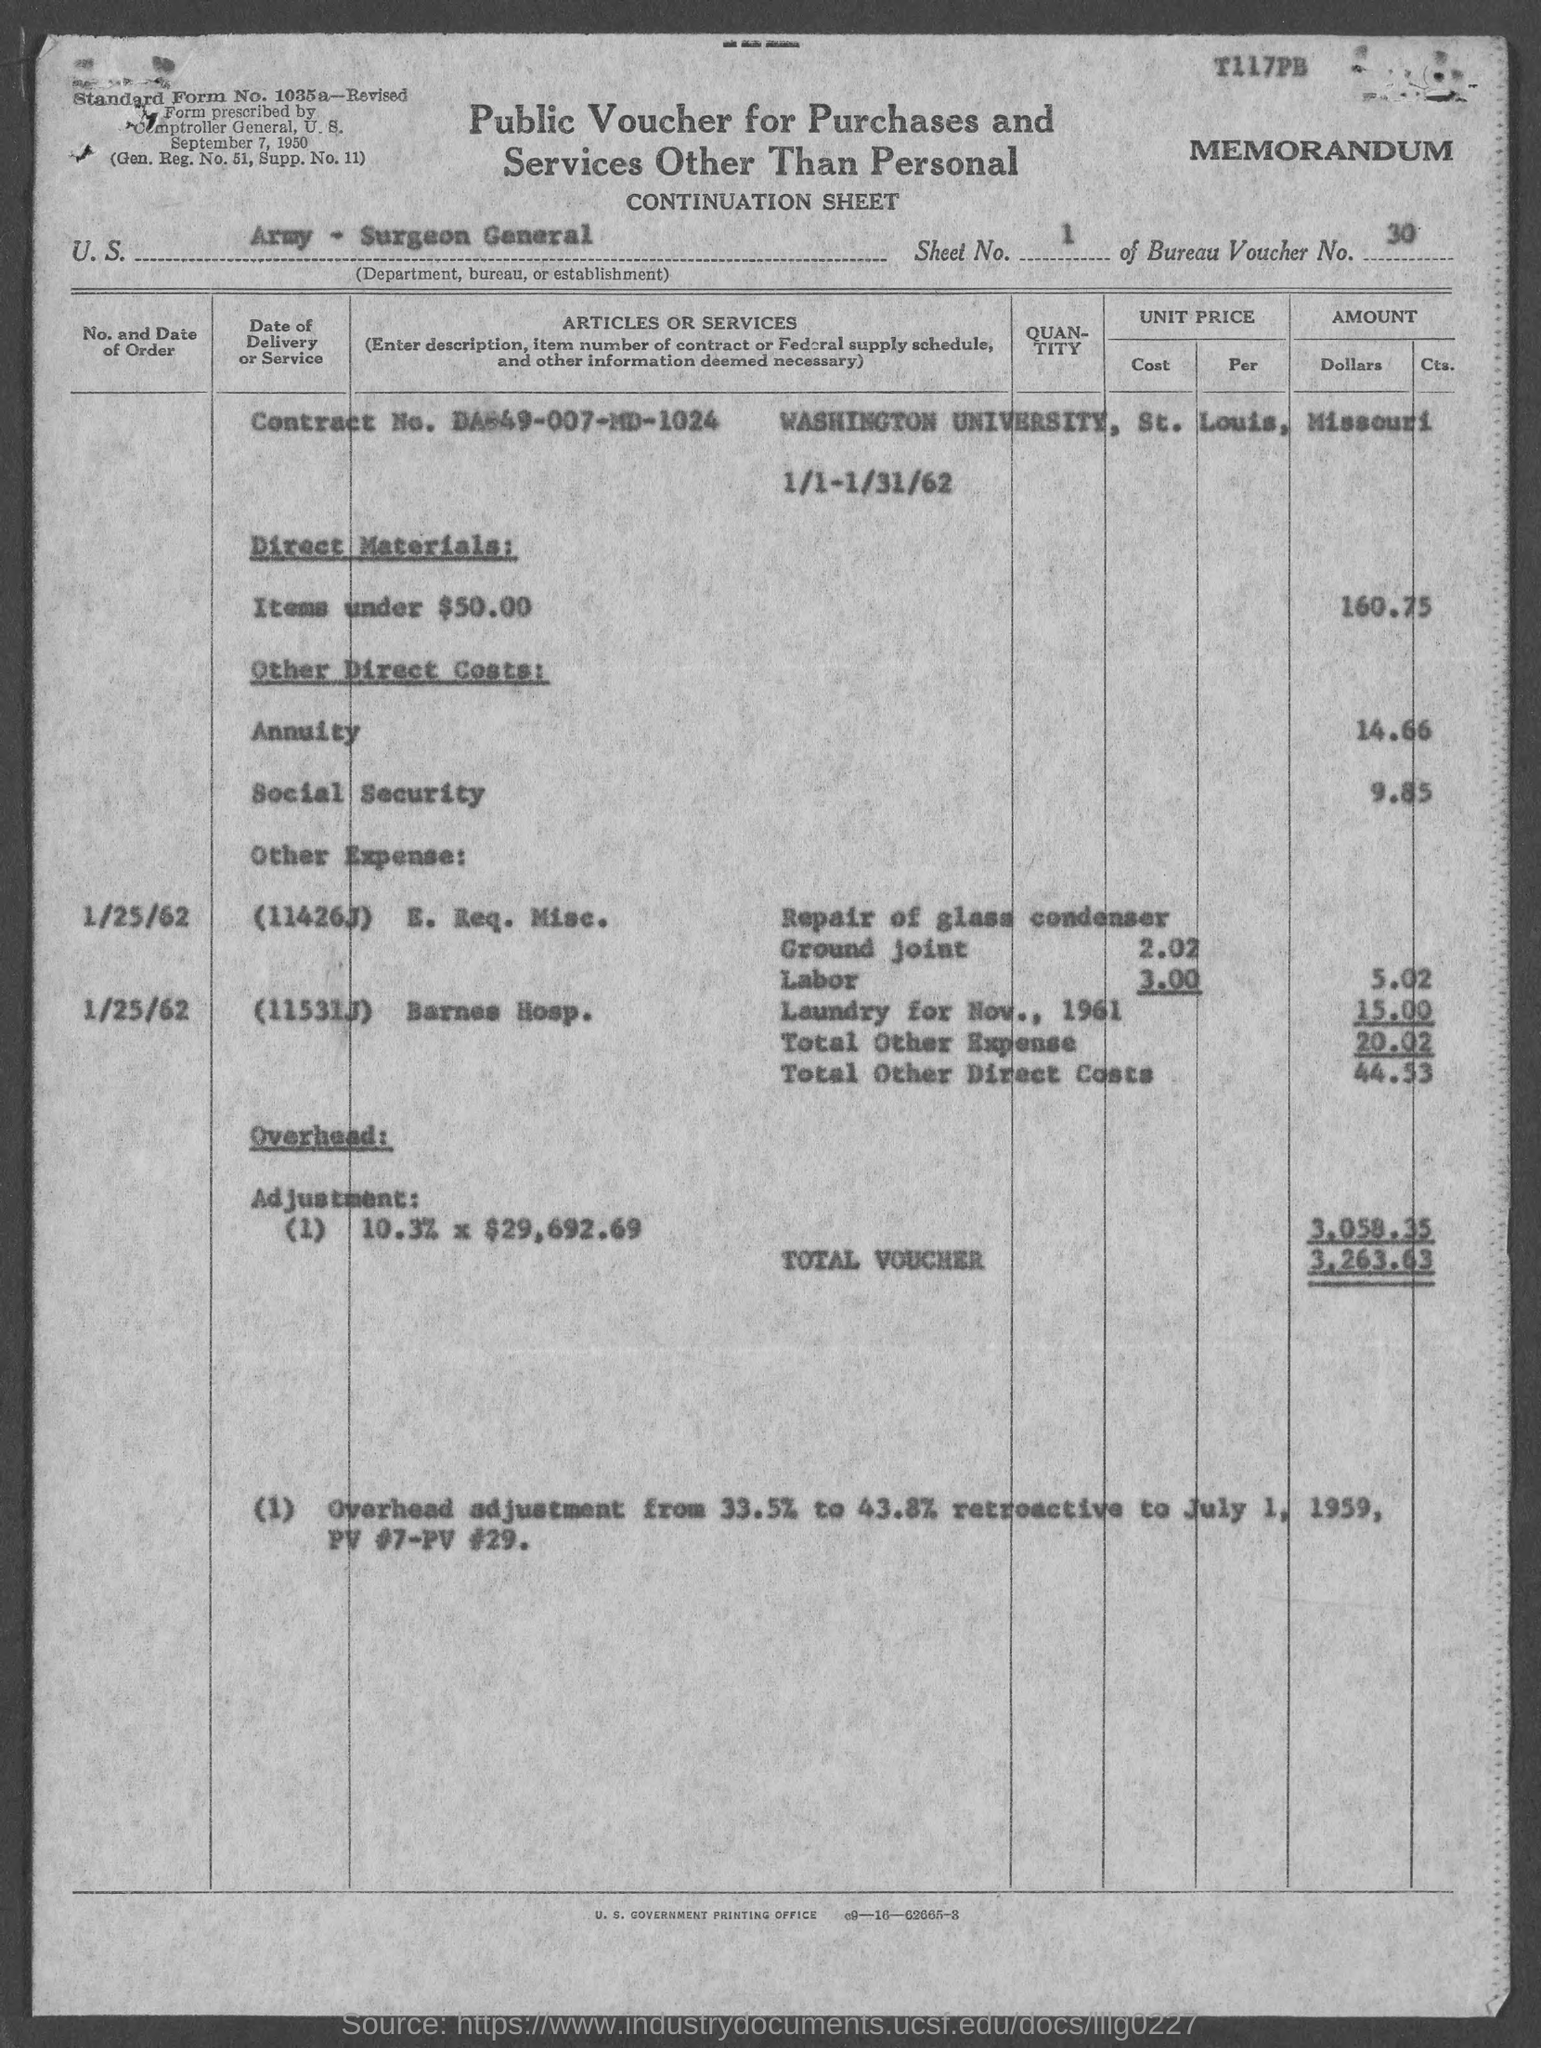Point out several critical features in this image. The Bureau Voucher Number is 30. The sheet number is 1...? The contract number is DA-49-007-MD-1024. What is the standard form number? 1035a.." is a question asking for information about a specific piece of information or data. The question is asking for the specific form number of a standard, which is a reference or guide that provides a set of rules, guidelines, or requirements for a particular task or process. 